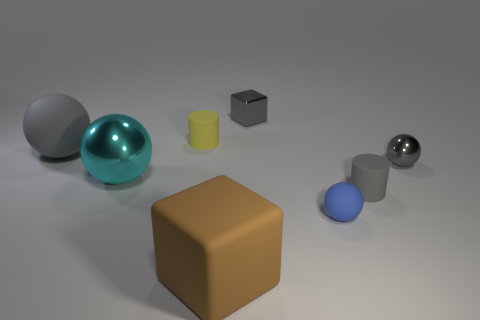Add 2 gray objects. How many objects exist? 10 Subtract all cylinders. How many objects are left? 6 Add 1 small metal blocks. How many small metal blocks are left? 2 Add 4 tiny blue spheres. How many tiny blue spheres exist? 5 Subtract 0 yellow balls. How many objects are left? 8 Subtract all large gray matte things. Subtract all large balls. How many objects are left? 5 